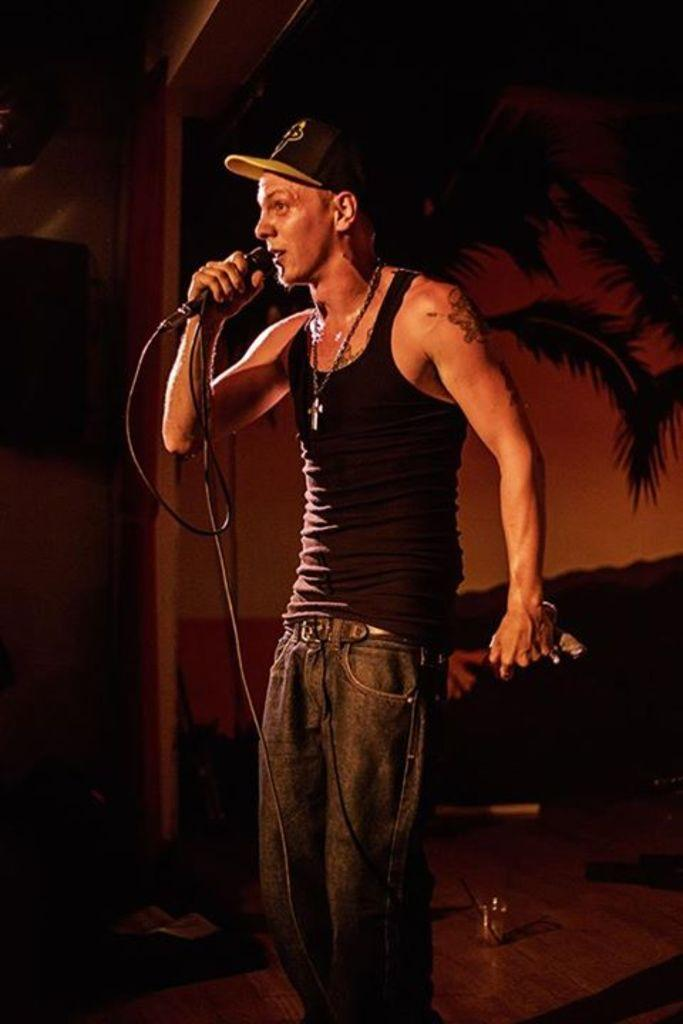What is the man in the image doing? The man is standing in the image and holding a microphone. What is the man wearing on his head? The man is wearing a wire cap. What can be seen on the surface in the image? There are objects on a surface in the image. What is visible in the background of the image? There is a screen and an object on a wall in the background of the image. What type of lip can be seen on the man's face in the image? There is no lip visible on the man's face in the image. How does the man express disgust in the image? There is no indication of the man expressing disgust in the image. 